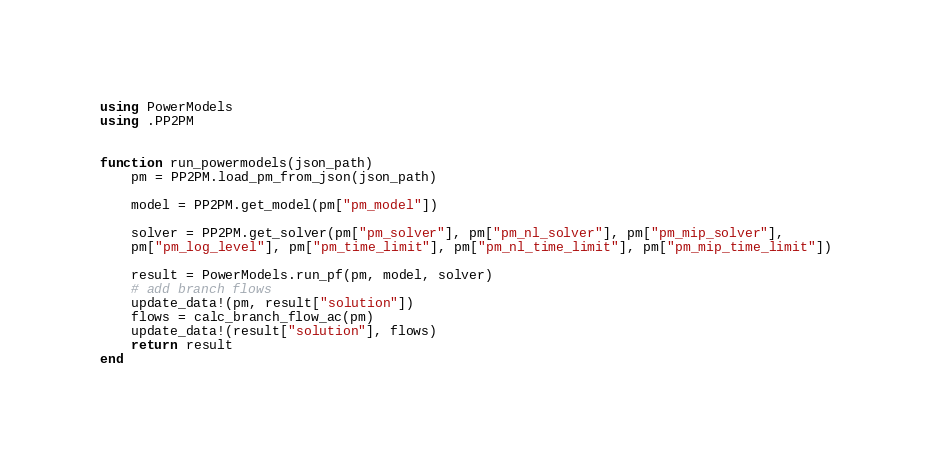Convert code to text. <code><loc_0><loc_0><loc_500><loc_500><_Julia_>using PowerModels
using .PP2PM


function run_powermodels(json_path)
    pm = PP2PM.load_pm_from_json(json_path)

    model = PP2PM.get_model(pm["pm_model"])
    
    solver = PP2PM.get_solver(pm["pm_solver"], pm["pm_nl_solver"], pm["pm_mip_solver"], 
    pm["pm_log_level"], pm["pm_time_limit"], pm["pm_nl_time_limit"], pm["pm_mip_time_limit"])
    
    result = PowerModels.run_pf(pm, model, solver)
    # add branch flows
    update_data!(pm, result["solution"])
    flows = calc_branch_flow_ac(pm)
    update_data!(result["solution"], flows)
    return result
end
</code> 